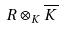<formula> <loc_0><loc_0><loc_500><loc_500>R \otimes _ { K } \overline { K }</formula> 